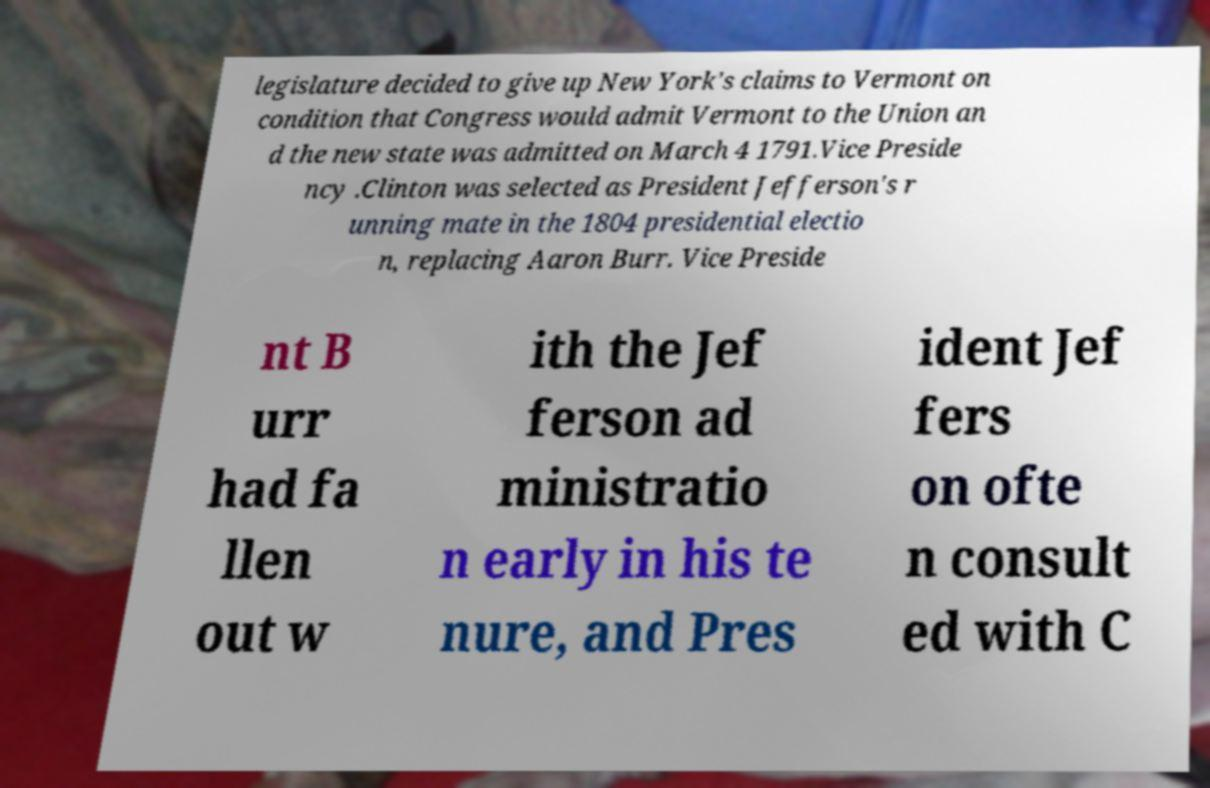There's text embedded in this image that I need extracted. Can you transcribe it verbatim? legislature decided to give up New York's claims to Vermont on condition that Congress would admit Vermont to the Union an d the new state was admitted on March 4 1791.Vice Preside ncy .Clinton was selected as President Jefferson's r unning mate in the 1804 presidential electio n, replacing Aaron Burr. Vice Preside nt B urr had fa llen out w ith the Jef ferson ad ministratio n early in his te nure, and Pres ident Jef fers on ofte n consult ed with C 